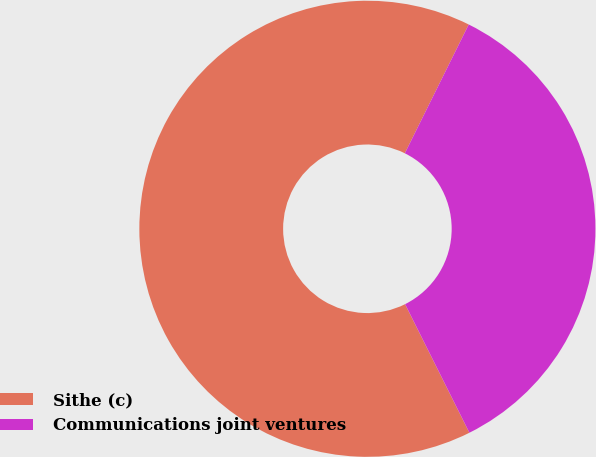Convert chart. <chart><loc_0><loc_0><loc_500><loc_500><pie_chart><fcel>Sithe (c)<fcel>Communications joint ventures<nl><fcel>64.71%<fcel>35.29%<nl></chart> 